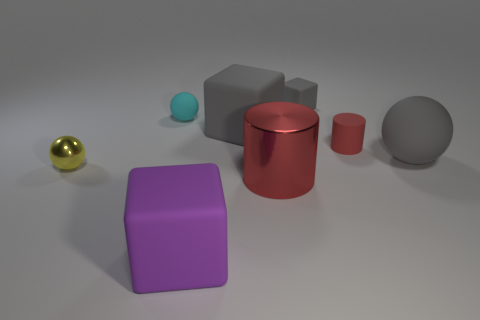What material is the red cylinder behind the big ball that is behind the large rubber cube in front of the big matte sphere made of?
Ensure brevity in your answer.  Rubber. Does the small gray thing have the same shape as the large purple object?
Offer a terse response. Yes. How many rubber objects are large red things or cubes?
Offer a terse response. 3. What number of gray rubber spheres are there?
Keep it short and to the point. 1. There is a rubber block that is the same size as the yellow metal sphere; what is its color?
Offer a very short reply. Gray. Do the cyan rubber ball and the rubber cylinder have the same size?
Make the answer very short. Yes. The object that is the same color as the tiny cylinder is what shape?
Provide a succinct answer. Cylinder. Do the red matte cylinder and the gray rubber object on the right side of the small rubber cube have the same size?
Your answer should be compact. No. There is a big matte thing that is both on the left side of the big ball and behind the purple matte object; what is its color?
Give a very brief answer. Gray. Are there more tiny objects that are behind the purple thing than metal things that are behind the big sphere?
Make the answer very short. Yes. 